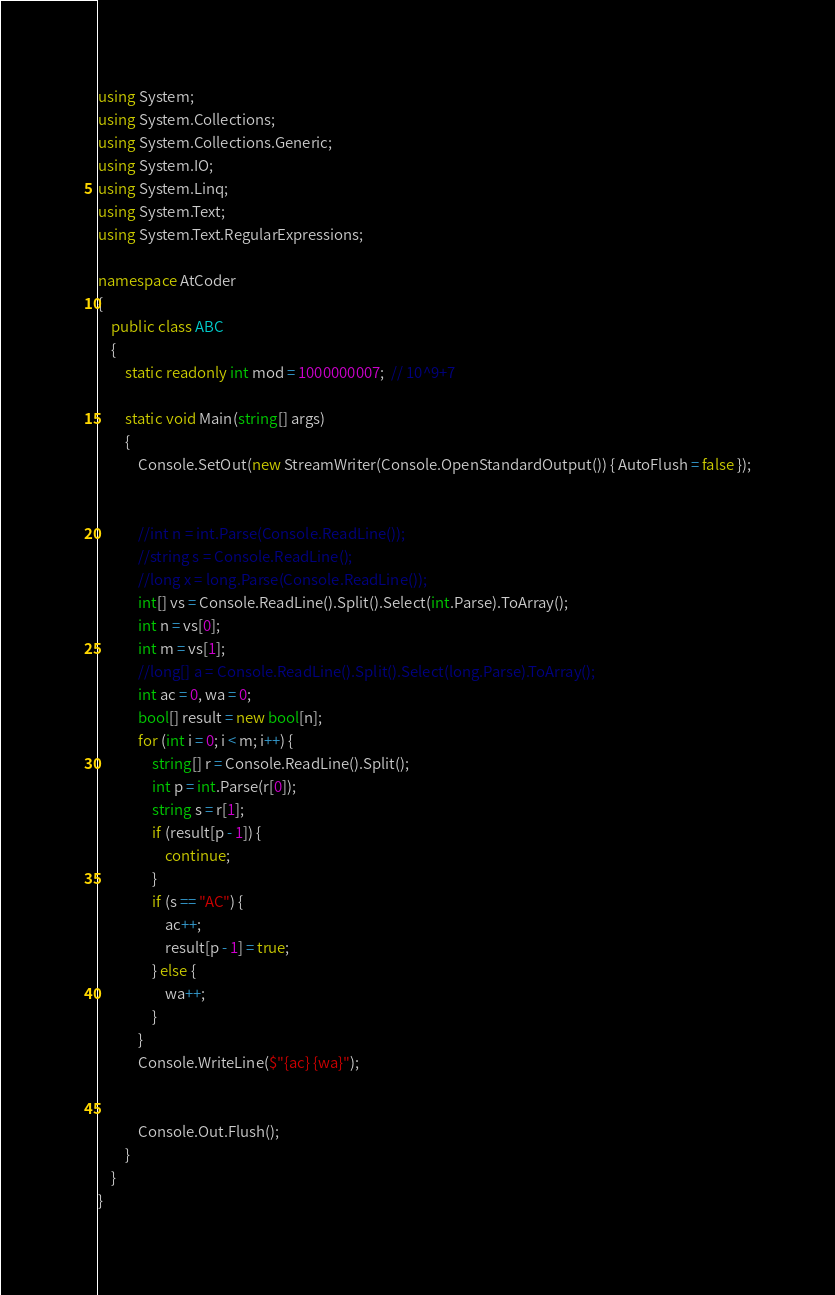<code> <loc_0><loc_0><loc_500><loc_500><_C#_>using System;
using System.Collections;
using System.Collections.Generic;
using System.IO;
using System.Linq;
using System.Text;
using System.Text.RegularExpressions;

namespace AtCoder
{
	public class ABC
	{
		static readonly int mod = 1000000007;  // 10^9+7

		static void Main(string[] args)
		{
			Console.SetOut(new StreamWriter(Console.OpenStandardOutput()) { AutoFlush = false });


			//int n = int.Parse(Console.ReadLine());
			//string s = Console.ReadLine();
			//long x = long.Parse(Console.ReadLine());
			int[] vs = Console.ReadLine().Split().Select(int.Parse).ToArray();
			int n = vs[0];
			int m = vs[1];
			//long[] a = Console.ReadLine().Split().Select(long.Parse).ToArray();
			int ac = 0, wa = 0;
			bool[] result = new bool[n];
			for (int i = 0; i < m; i++) {
				string[] r = Console.ReadLine().Split();
				int p = int.Parse(r[0]);
				string s = r[1];
				if (result[p - 1]) {
					continue;
				}
				if (s == "AC") {
					ac++;
					result[p - 1] = true;
				} else {
					wa++;
				}
			}
			Console.WriteLine($"{ac} {wa}");


			Console.Out.Flush();
		}
	}
}
</code> 